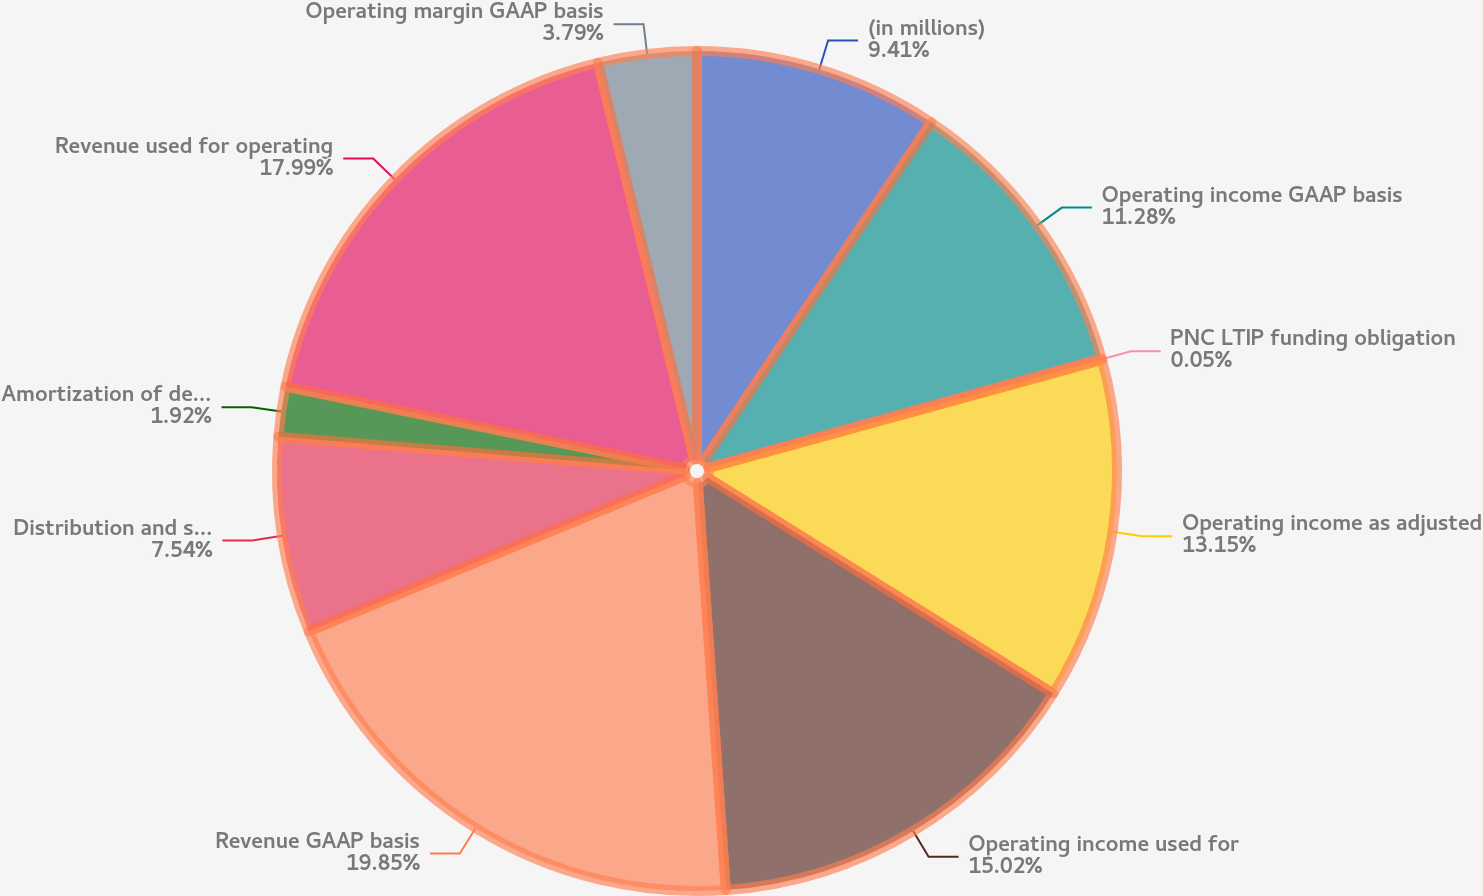Convert chart to OTSL. <chart><loc_0><loc_0><loc_500><loc_500><pie_chart><fcel>(in millions)<fcel>Operating income GAAP basis<fcel>PNC LTIP funding obligation<fcel>Operating income as adjusted<fcel>Operating income used for<fcel>Revenue GAAP basis<fcel>Distribution and servicing<fcel>Amortization of deferred sales<fcel>Revenue used for operating<fcel>Operating margin GAAP basis<nl><fcel>9.41%<fcel>11.28%<fcel>0.05%<fcel>13.15%<fcel>15.02%<fcel>19.86%<fcel>7.54%<fcel>1.92%<fcel>17.99%<fcel>3.79%<nl></chart> 